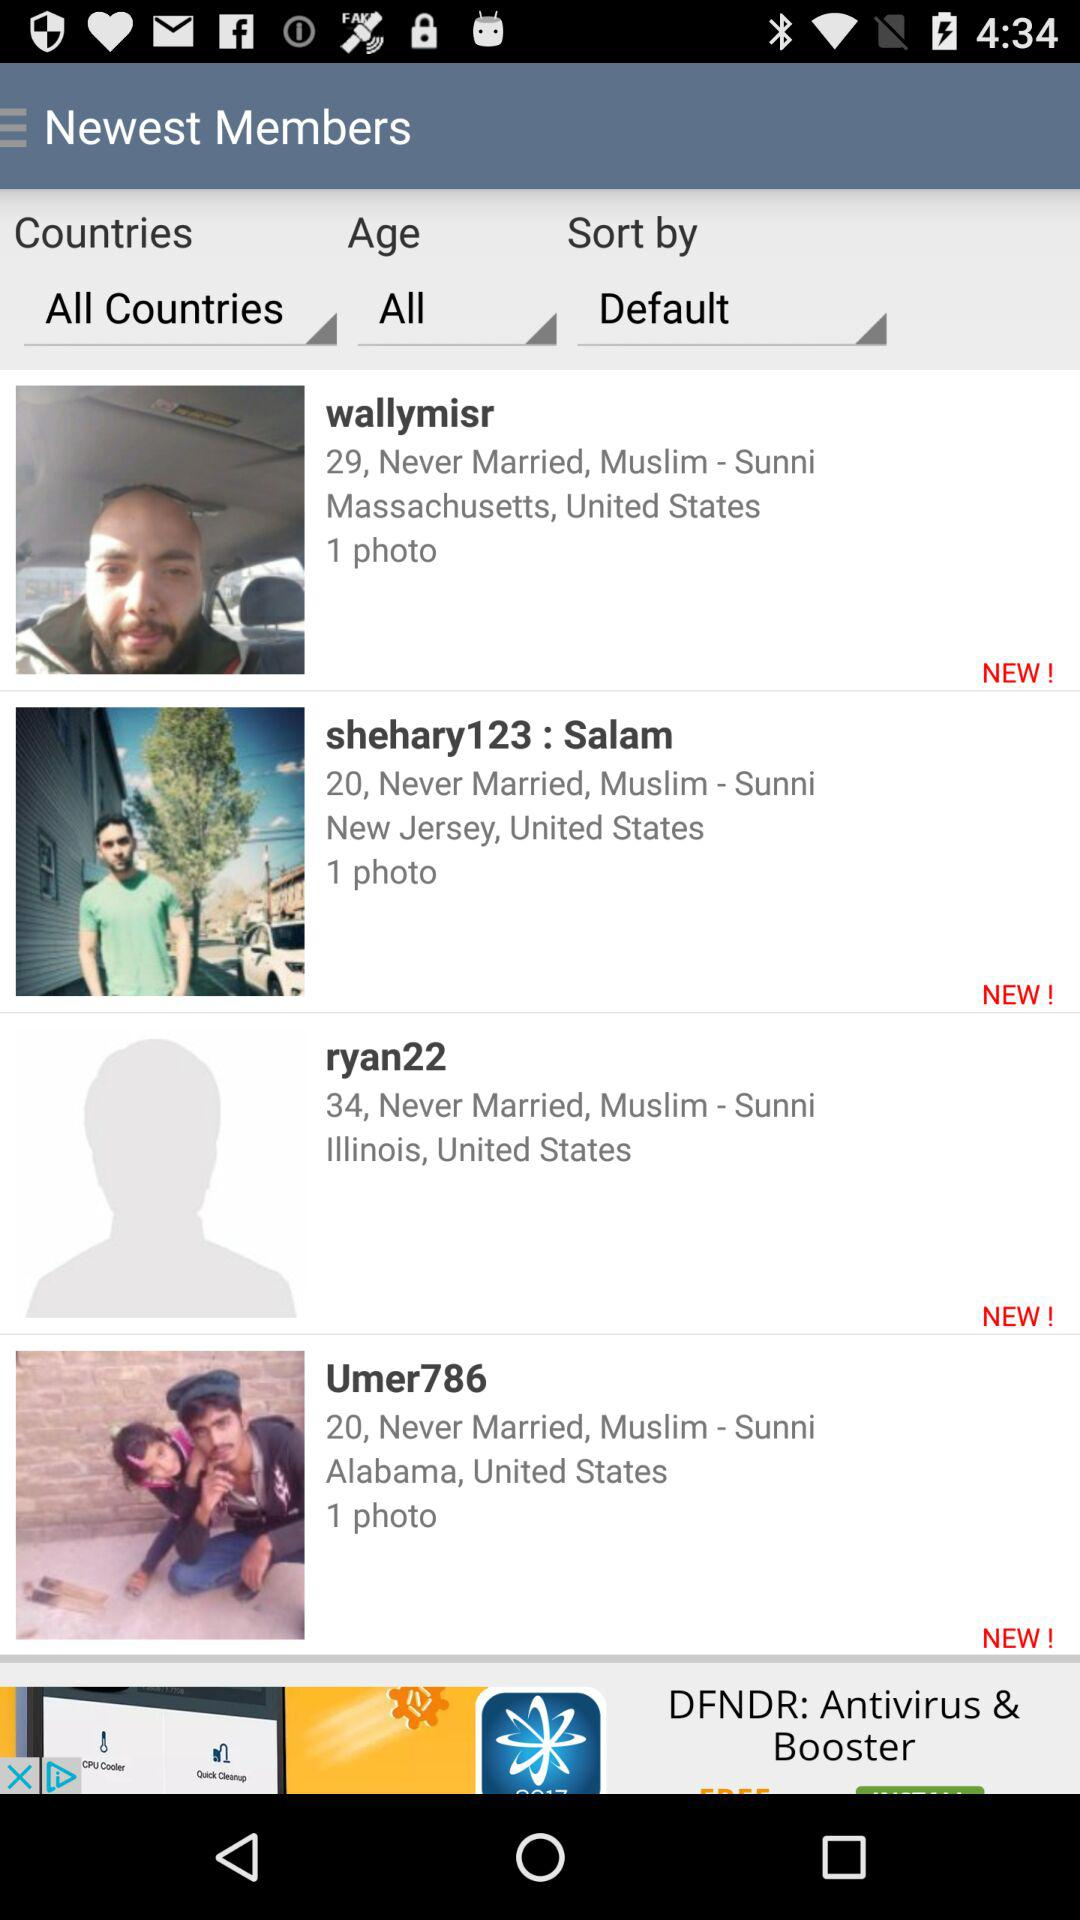How many photos are uploaded by "wallymisr"? There is 1 photo uploaded by "wallymisr". 